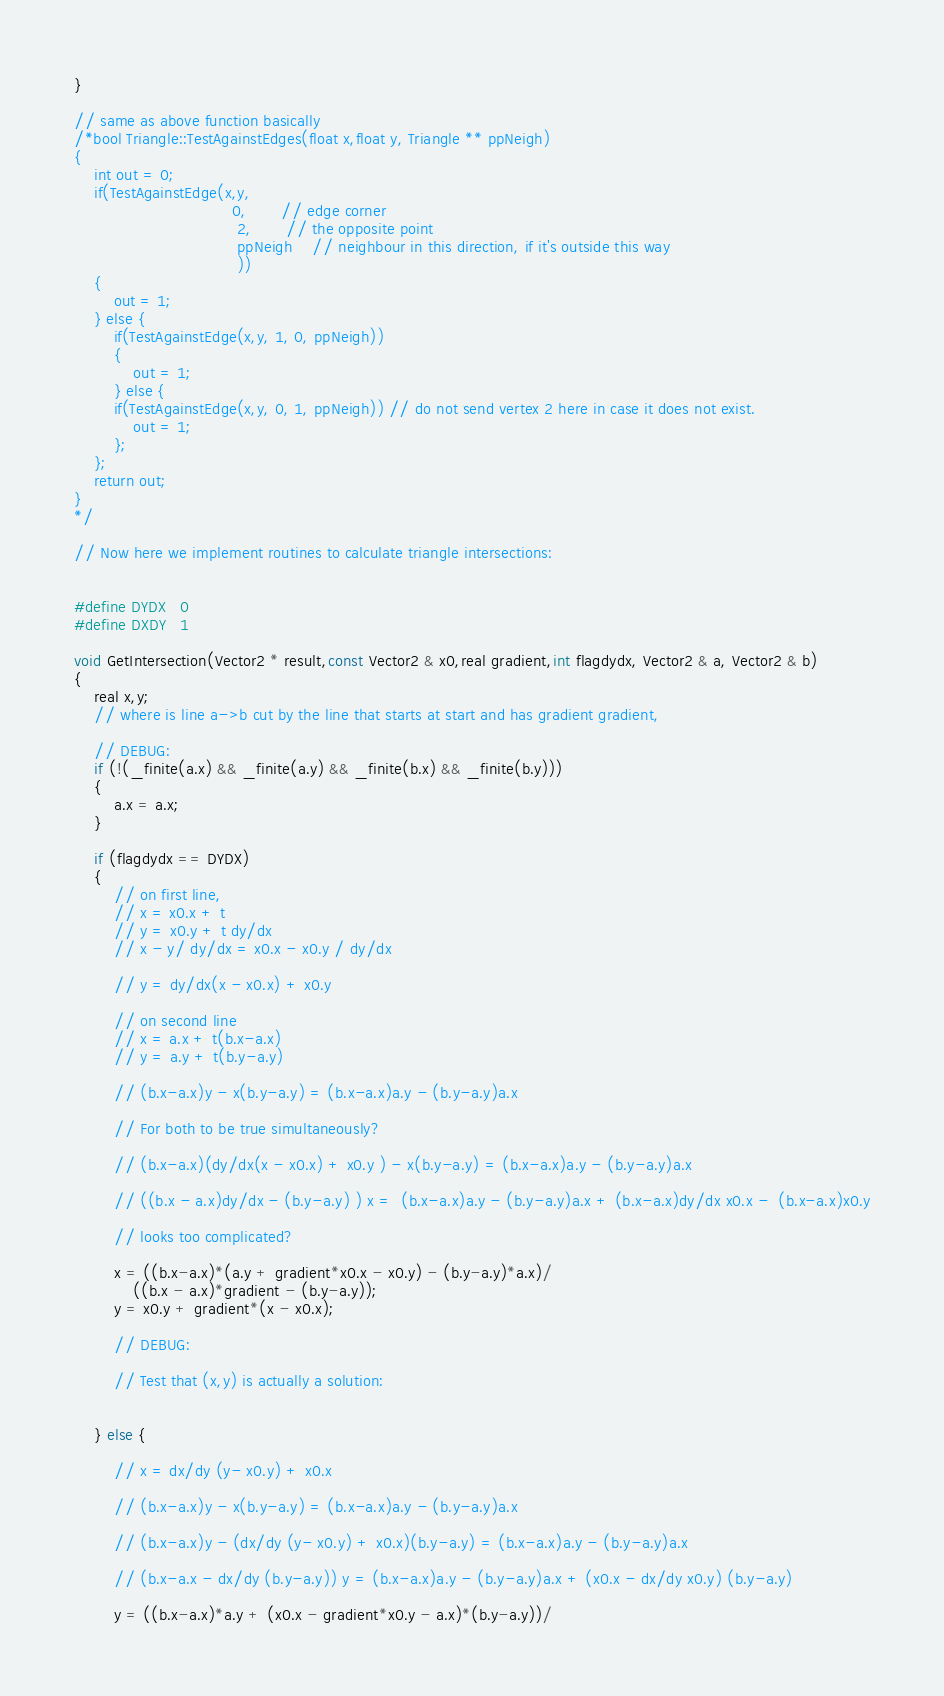Convert code to text. <code><loc_0><loc_0><loc_500><loc_500><_Cuda_>}			

// same as above function basically
/*bool Triangle::TestAgainstEdges(float x,float y, Triangle ** ppNeigh)
{
	int out = 0;
	if(TestAgainstEdge(x,y,
								0,       // edge corner
								 2,       // the opposite point
								 ppNeigh    // neighbour in this direction, if it's outside this way
								 ))
	{
		out = 1;
	} else {
		if(TestAgainstEdge(x,y, 1, 0, ppNeigh))
		{
			out = 1;
		} else {
		if(TestAgainstEdge(x,y, 0, 1, ppNeigh)) // do not send vertex 2 here in case it does not exist.
			out = 1;
		};
	};
	return out;	
}			
*/

// Now here we implement routines to calculate triangle intersections:


#define DYDX   0
#define DXDY   1

void GetIntersection(Vector2 * result,const Vector2 & x0,real gradient,int flagdydx, Vector2 & a, Vector2 & b)
{
	real x,y;
	// where is line a->b cut by the line that starts at start and has gradient gradient,

	// DEBUG:
	if (!(_finite(a.x) && _finite(a.y) && _finite(b.x) && _finite(b.y)))
	{
		a.x = a.x;
	}

	if (flagdydx == DYDX)
	{
		// on first line, 
		// x = x0.x + t
		// y = x0.y + t dy/dx
		// x - y/ dy/dx = x0.x - x0.y / dy/dx

		// y = dy/dx(x - x0.x) + x0.y 

		// on second line
		// x = a.x + t(b.x-a.x)
		// y = a.y + t(b.y-a.y)

		// (b.x-a.x)y - x(b.y-a.y) = (b.x-a.x)a.y - (b.y-a.y)a.x
		
		// For both to be true simultaneously?

		// (b.x-a.x)(dy/dx(x - x0.x) + x0.y ) - x(b.y-a.y) = (b.x-a.x)a.y - (b.y-a.y)a.x

		// ((b.x - a.x)dy/dx - (b.y-a.y) ) x =  (b.x-a.x)a.y - (b.y-a.y)a.x + (b.x-a.x)dy/dx x0.x -  (b.x-a.x)x0.y
		
		// looks too complicated?

		x = ((b.x-a.x)*(a.y + gradient*x0.x - x0.y) - (b.y-a.y)*a.x)/
			((b.x - a.x)*gradient - (b.y-a.y));
		y = x0.y + gradient*(x - x0.x);

		// DEBUG:

		// Test that (x,y) is actually a solution:


	} else {

		// x = dx/dy (y- x0.y) + x0.x

		// (b.x-a.x)y - x(b.y-a.y) = (b.x-a.x)a.y - (b.y-a.y)a.x

		// (b.x-a.x)y - (dx/dy (y- x0.y) + x0.x)(b.y-a.y) = (b.x-a.x)a.y - (b.y-a.y)a.x

		// (b.x-a.x - dx/dy (b.y-a.y)) y = (b.x-a.x)a.y - (b.y-a.y)a.x + (x0.x - dx/dy x0.y) (b.y-a.y)

		y = ((b.x-a.x)*a.y + (x0.x - gradient*x0.y - a.x)*(b.y-a.y))/</code> 